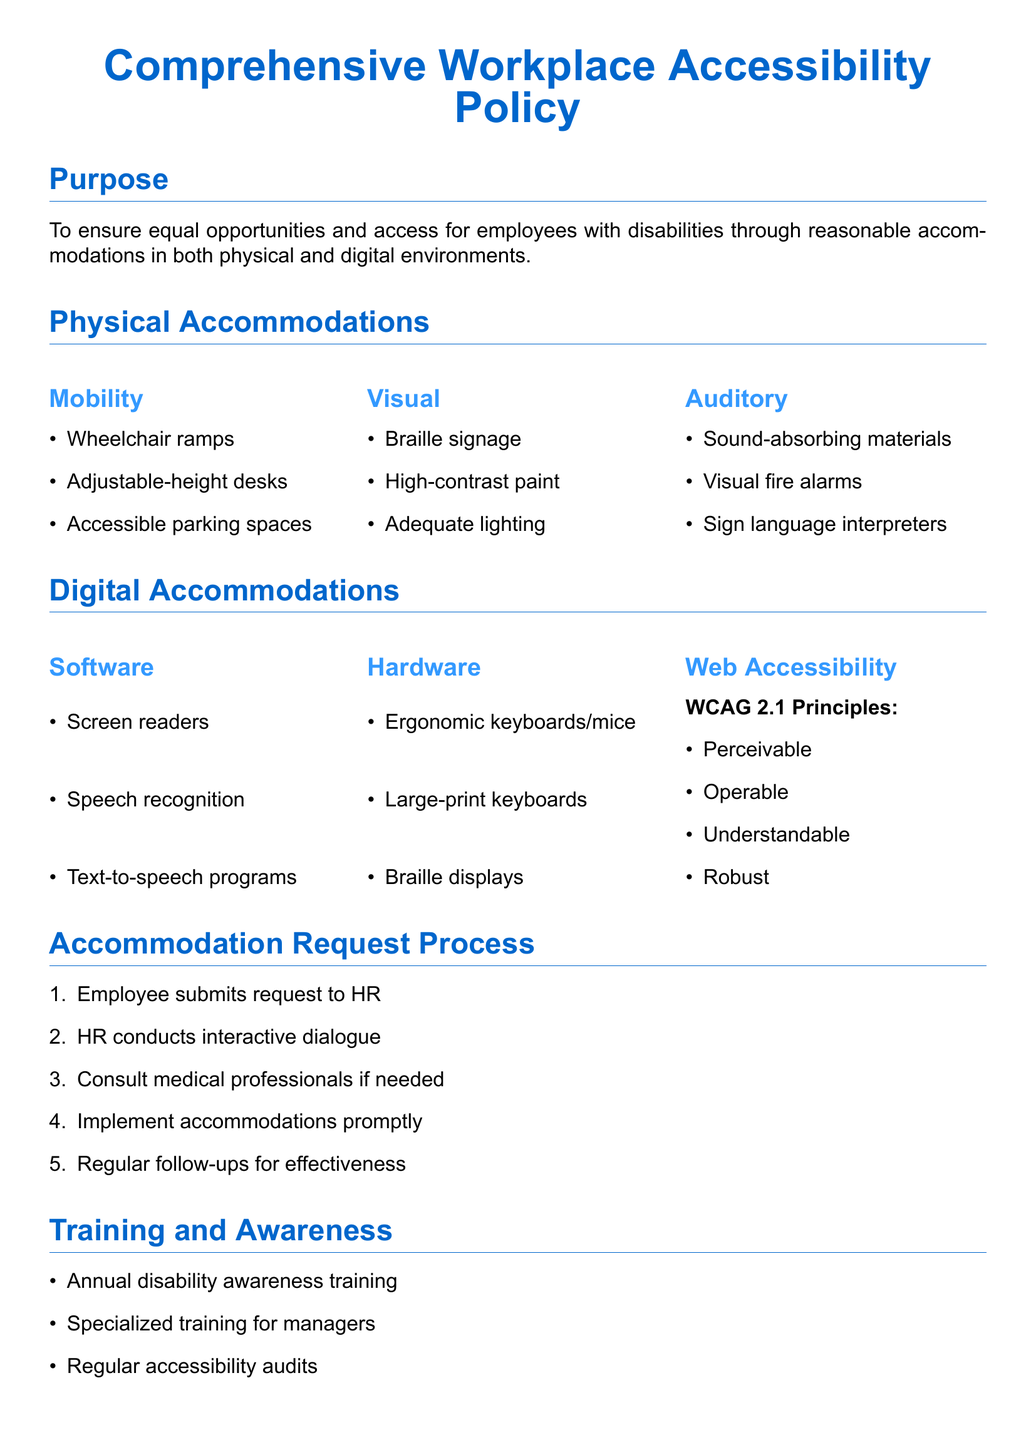What is the purpose of the policy? The purpose outlines the main objective of the policy to ensure equal opportunities and access for employees with disabilities.
Answer: To ensure equal opportunities and access for employees with disabilities through reasonable accommodations in both physical and digital environments How many categories are there for physical accommodations? The document lists three categories under physical accommodations: Mobility, Visual, and Auditory.
Answer: 3 What is one example of a visual accommodation? This question asks for a specific example from the visual accommodations listed.
Answer: Braille signage What does WCAG stand for in the context of web accessibility? The question requires the retrieval of the acronym used in the document related to web accessibility principles.
Answer: Web Content Accessibility Guidelines What is the first step in the accommodation request process? This question asks for the initial action required by the employee in the accommodation process.
Answer: Employee submits request to HR What type of training is included in the Training and Awareness section? The question asks for a specific type of training mentioned in the document that relates to employee awareness.
Answer: Annual disability awareness training How often is the policy reviewed? This question requires the retrieval of the frequency of the policy review mentioned in the compliance section.
Answer: Annual What is one of the laws mentioned in the compliance section? This question asks for an example of legislation listed in the compliance section.
Answer: ADA 